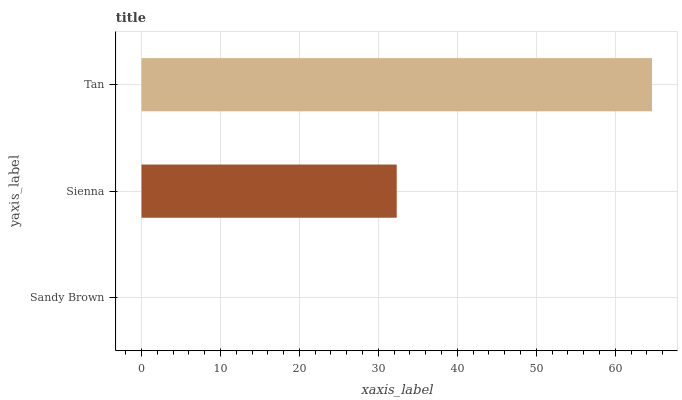Is Sandy Brown the minimum?
Answer yes or no. Yes. Is Tan the maximum?
Answer yes or no. Yes. Is Sienna the minimum?
Answer yes or no. No. Is Sienna the maximum?
Answer yes or no. No. Is Sienna greater than Sandy Brown?
Answer yes or no. Yes. Is Sandy Brown less than Sienna?
Answer yes or no. Yes. Is Sandy Brown greater than Sienna?
Answer yes or no. No. Is Sienna less than Sandy Brown?
Answer yes or no. No. Is Sienna the high median?
Answer yes or no. Yes. Is Sienna the low median?
Answer yes or no. Yes. Is Tan the high median?
Answer yes or no. No. Is Sandy Brown the low median?
Answer yes or no. No. 